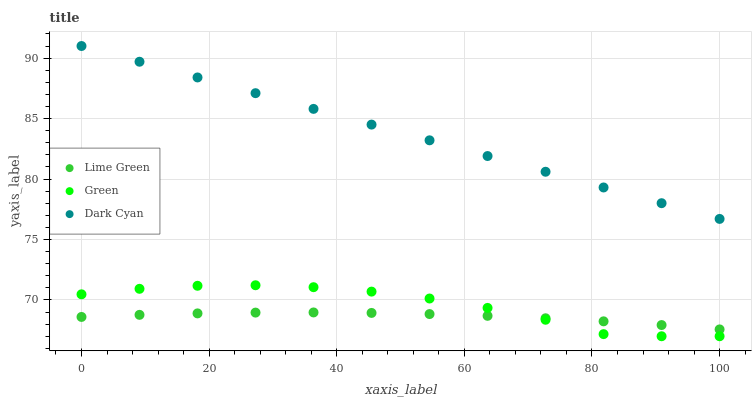Does Lime Green have the minimum area under the curve?
Answer yes or no. Yes. Does Dark Cyan have the maximum area under the curve?
Answer yes or no. Yes. Does Green have the minimum area under the curve?
Answer yes or no. No. Does Green have the maximum area under the curve?
Answer yes or no. No. Is Dark Cyan the smoothest?
Answer yes or no. Yes. Is Green the roughest?
Answer yes or no. Yes. Is Lime Green the smoothest?
Answer yes or no. No. Is Lime Green the roughest?
Answer yes or no. No. Does Green have the lowest value?
Answer yes or no. Yes. Does Lime Green have the lowest value?
Answer yes or no. No. Does Dark Cyan have the highest value?
Answer yes or no. Yes. Does Green have the highest value?
Answer yes or no. No. Is Green less than Dark Cyan?
Answer yes or no. Yes. Is Dark Cyan greater than Green?
Answer yes or no. Yes. Does Green intersect Lime Green?
Answer yes or no. Yes. Is Green less than Lime Green?
Answer yes or no. No. Is Green greater than Lime Green?
Answer yes or no. No. Does Green intersect Dark Cyan?
Answer yes or no. No. 